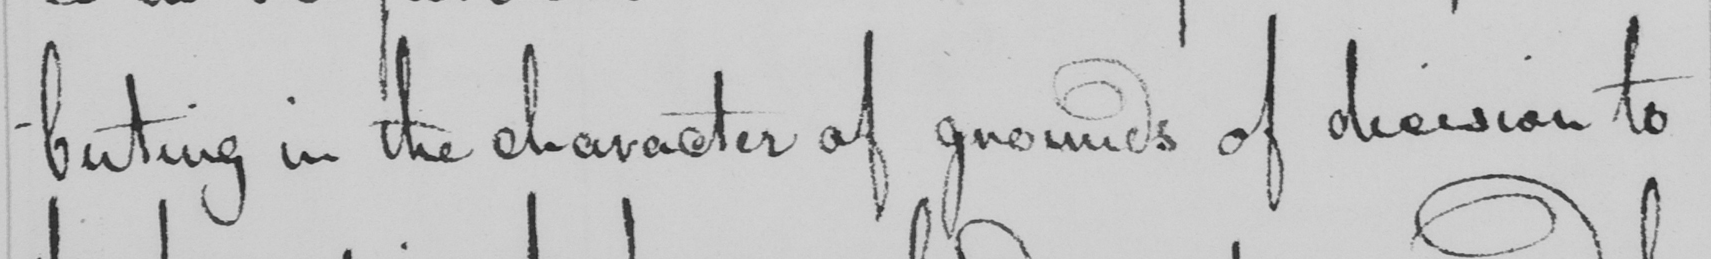Please provide the text content of this handwritten line. -buting in the character of grounds of decision to 